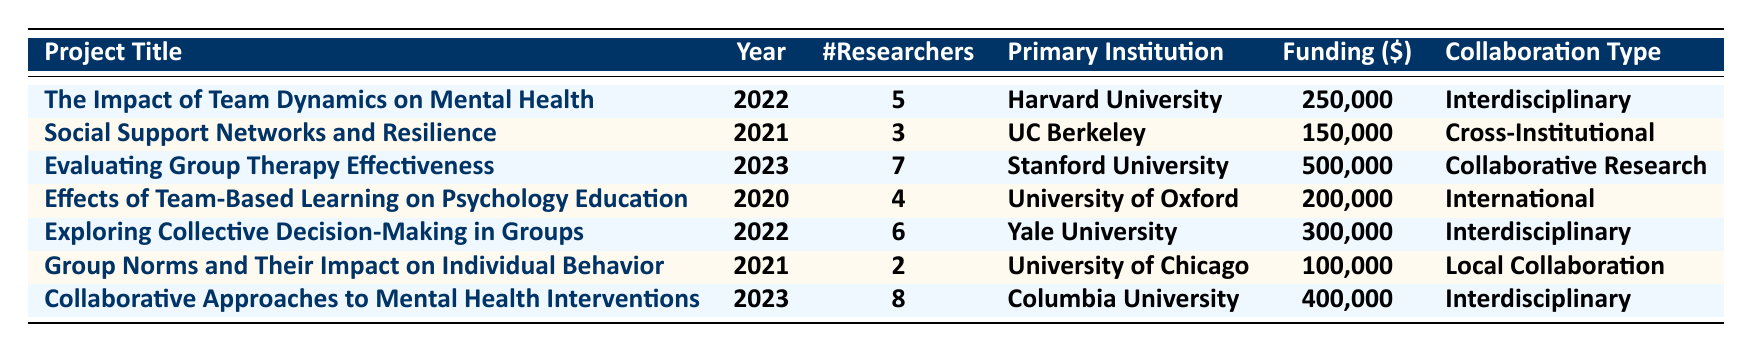What is the total funding amount for all the projects listed? To find the total funding amount, we need to sum the funding amounts of each project: 250,000 + 150,000 + 500,000 + 200,000 + 300,000 + 100,000 + 400,000 = 1,900,000.
Answer: 1,900,000 Which project has the highest number of researchers? By examining the "Number of Researchers" column, we see that "Collaborative Approaches to Mental Health Interventions" has 8 researchers, which is the maximum compared to the others.
Answer: Collaborative Approaches to Mental Health Interventions In what year was the project "Group Norms and Their Impact on Individual Behavior" conducted? The table shows the year listed for this project is 2021.
Answer: 2021 How many projects were conducted in 2023? There are two projects listed for the year 2023: "Evaluating Group Therapy Effectiveness" and "Collaborative Approaches to Mental Health Interventions."
Answer: 2 What is the total number of researchers across all projects? Summing the numbers of researchers from each project gives us: 5 + 3 + 7 + 4 + 6 + 2 + 8 = 35.
Answer: 35 Is "Yale University" the primary institution for any project listed in 2021? The table shows that Yale University is not listed under the 2021 projects; therefore, the answer is no.
Answer: No What is the average funding amount per project? To calculate the average funding, add the total funding (1,900,000) and divide it by the number of projects (7): 1,900,000 / 7 ≈ 271,429.
Answer: 271,429 Which type of collaboration was most common among the listed projects? Upon reviewing the "Collaboration Type" column, Interdisciplinary collaboration appears 3 times, more than any other type, making it the most common.
Answer: Interdisciplinary What is the difference between the funding amounts for the highest and lowest funded projects? The highest funded project is "Evaluating Group Therapy Effectiveness" with $500,000 and the lowest is "Group Norms and Their Impact on Individual Behavior" with $100,000. The difference is 500,000 - 100,000 = 400,000.
Answer: 400,000 How many projects have a collaboration type categorized as "International"? Only one project, "Effects of Team-Based Learning on Psychology Education," is categorized as "International" according to the table.
Answer: 1 